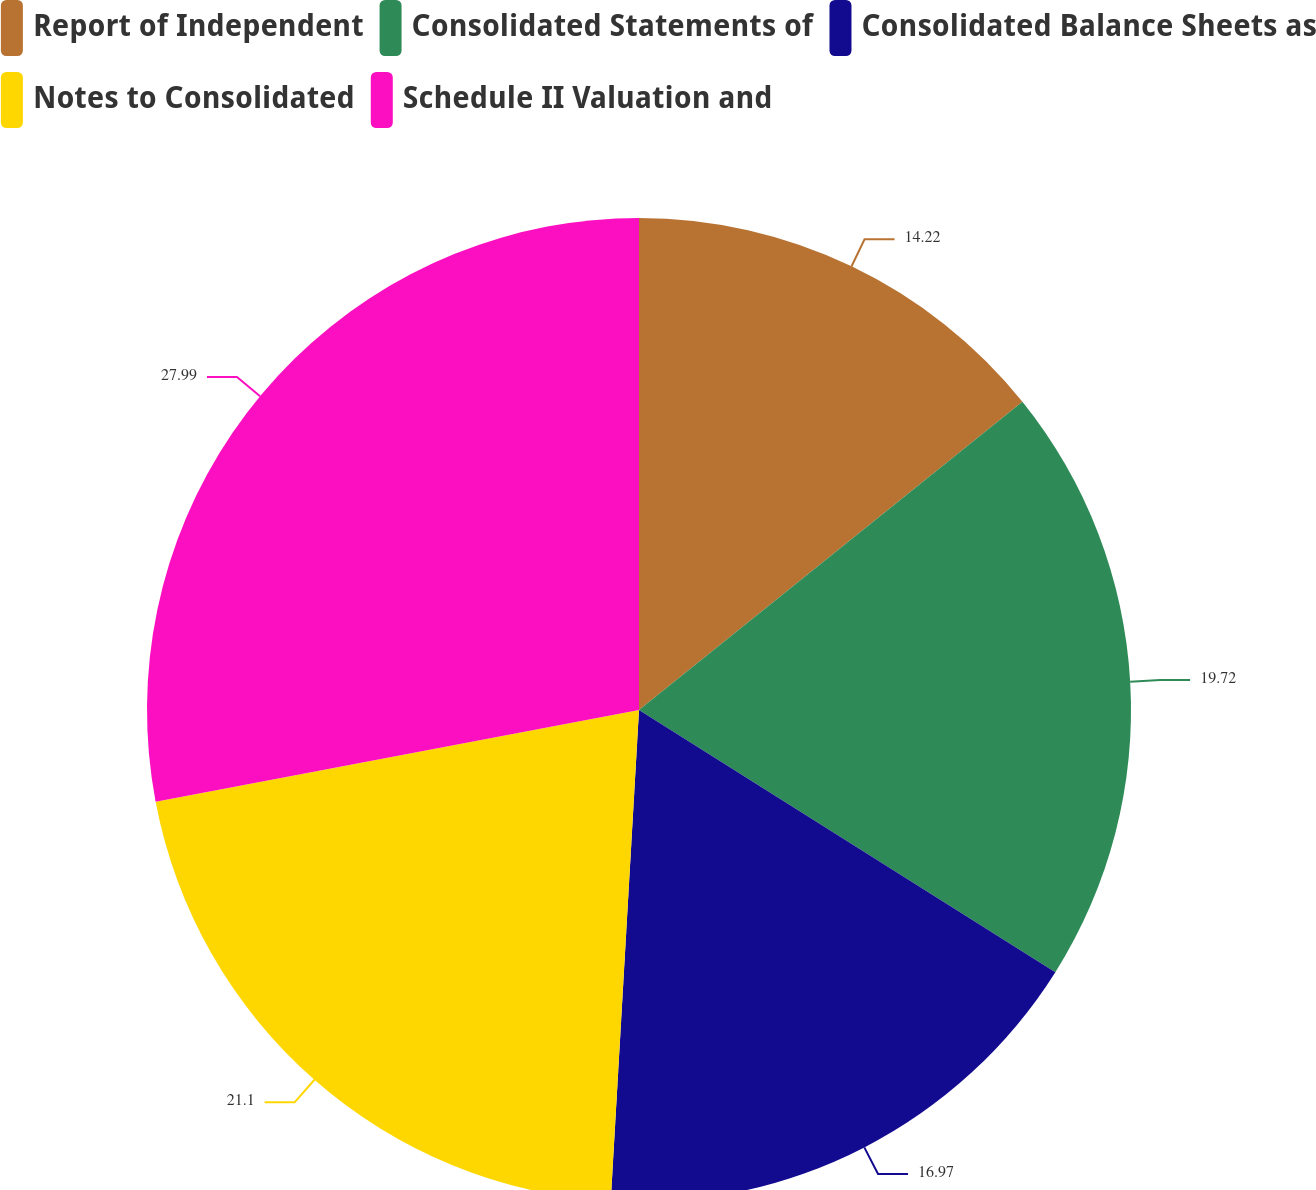Convert chart to OTSL. <chart><loc_0><loc_0><loc_500><loc_500><pie_chart><fcel>Report of Independent<fcel>Consolidated Statements of<fcel>Consolidated Balance Sheets as<fcel>Notes to Consolidated<fcel>Schedule II Valuation and<nl><fcel>14.22%<fcel>19.72%<fcel>16.97%<fcel>21.1%<fcel>27.98%<nl></chart> 